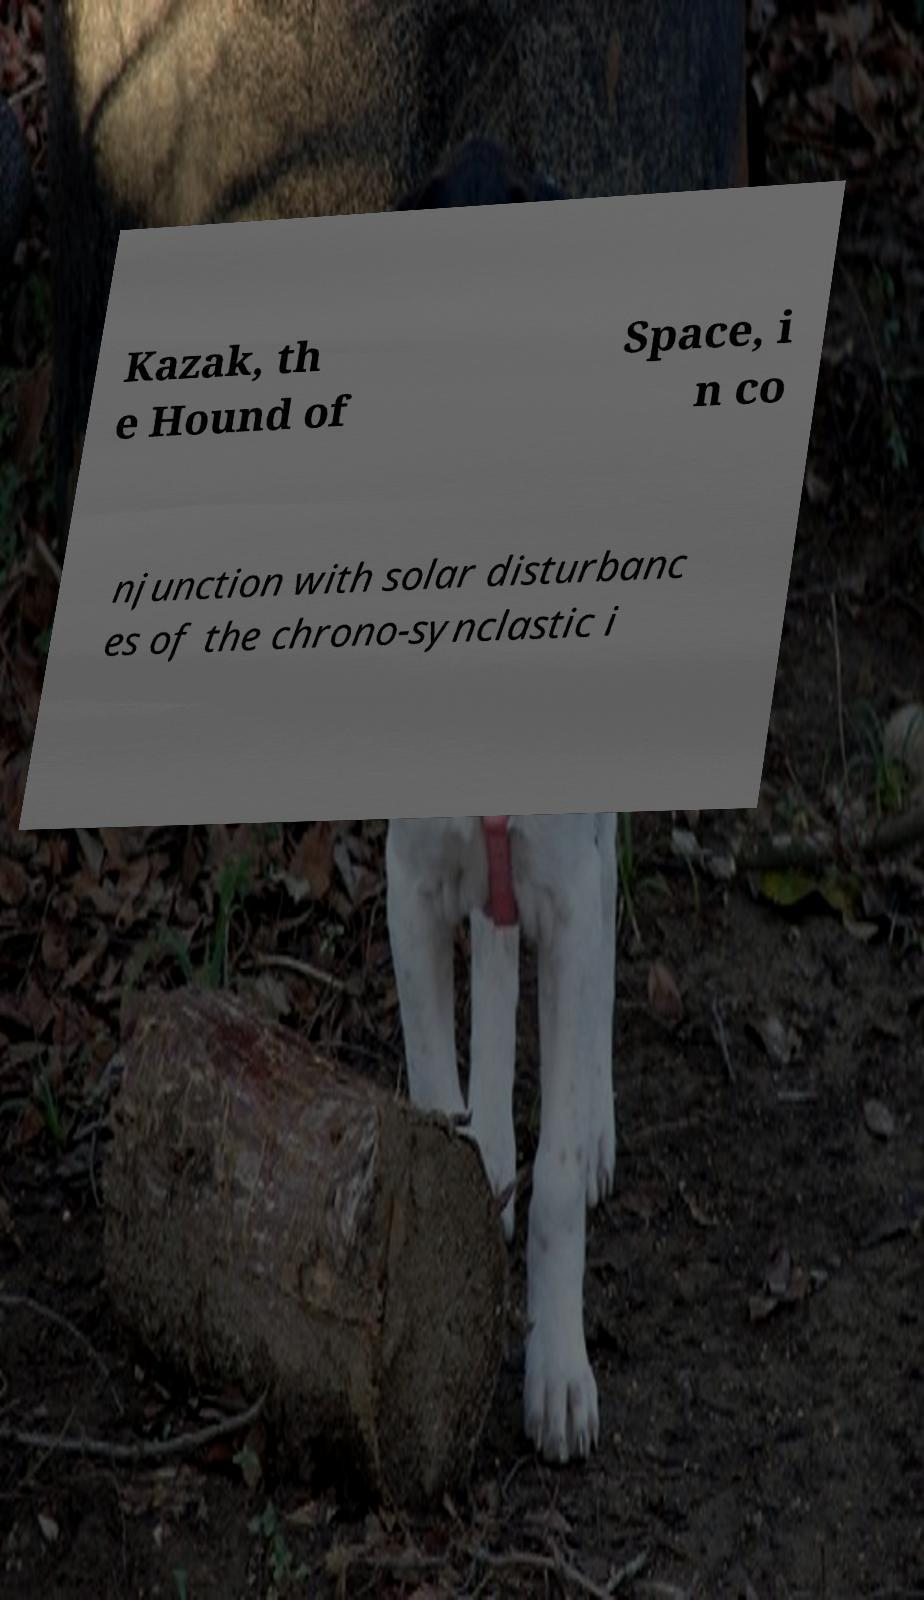For documentation purposes, I need the text within this image transcribed. Could you provide that? Kazak, th e Hound of Space, i n co njunction with solar disturbanc es of the chrono-synclastic i 